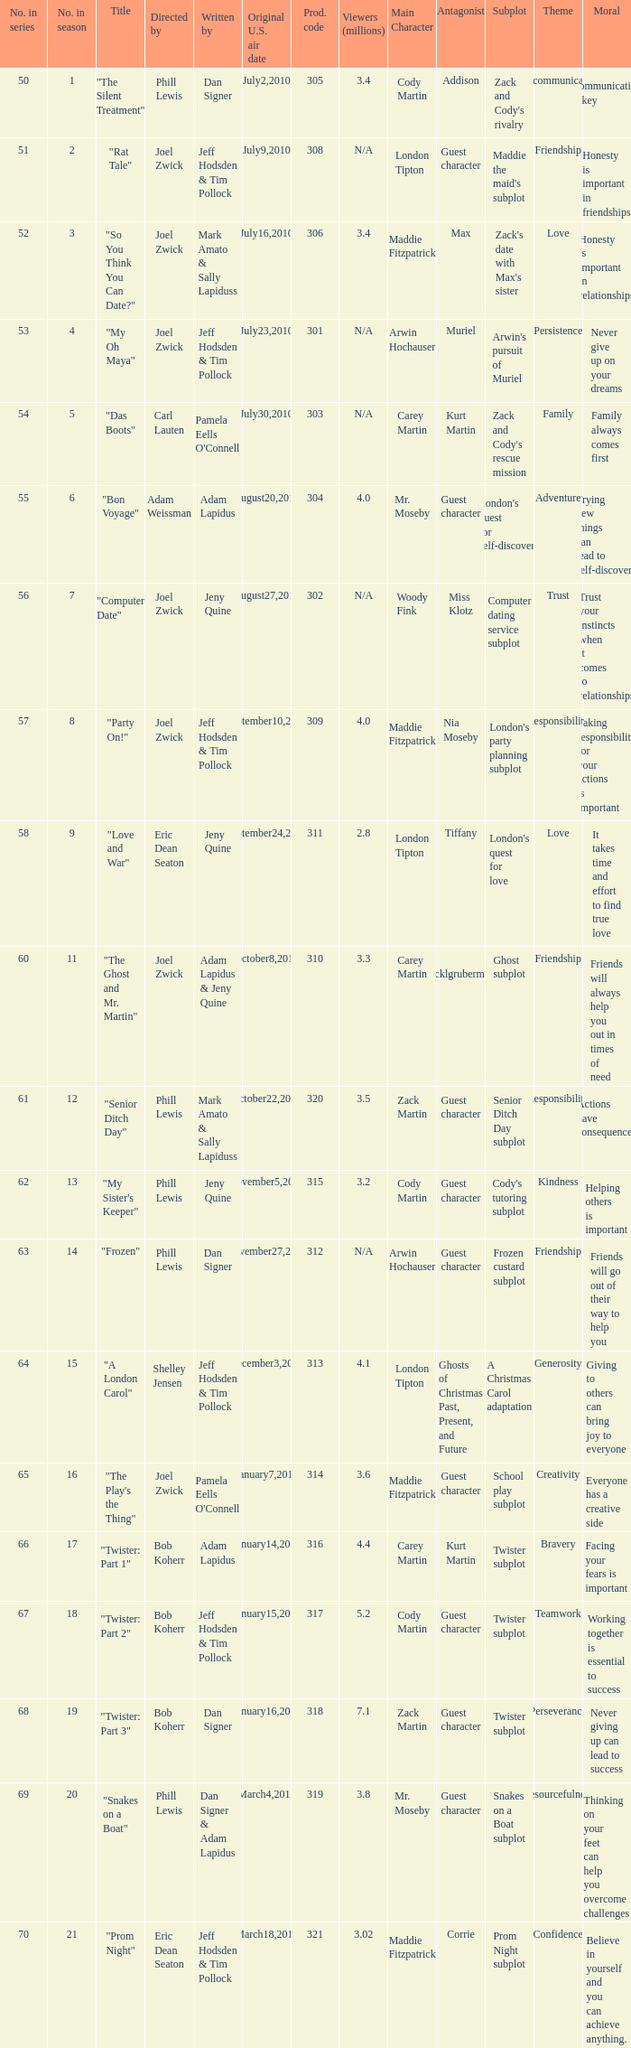Who was the directed for the episode titled "twister: part 1"? Bob Koherr. 